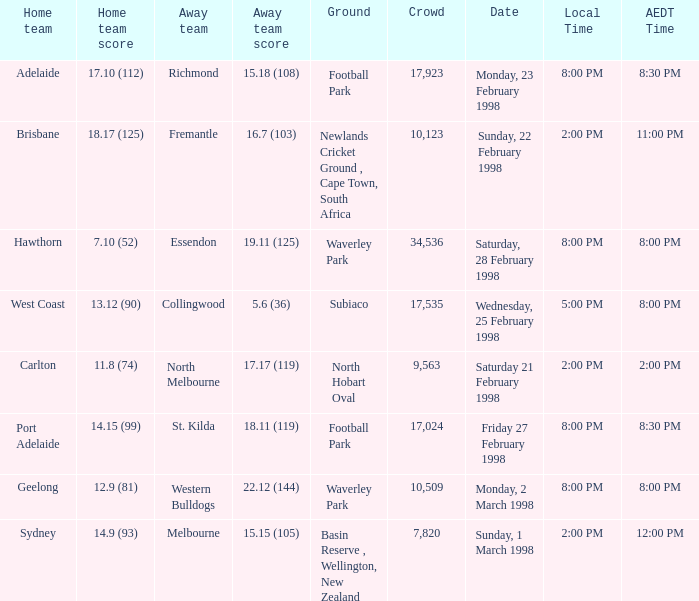Could you help me parse every detail presented in this table? {'header': ['Home team', 'Home team score', 'Away team', 'Away team score', 'Ground', 'Crowd', 'Date', 'Local Time', 'AEDT Time'], 'rows': [['Adelaide', '17.10 (112)', 'Richmond', '15.18 (108)', 'Football Park', '17,923', 'Monday, 23 February 1998', '8:00 PM', '8:30 PM'], ['Brisbane', '18.17 (125)', 'Fremantle', '16.7 (103)', 'Newlands Cricket Ground , Cape Town, South Africa', '10,123', 'Sunday, 22 February 1998', '2:00 PM', '11:00 PM'], ['Hawthorn', '7.10 (52)', 'Essendon', '19.11 (125)', 'Waverley Park', '34,536', 'Saturday, 28 February 1998', '8:00 PM', '8:00 PM'], ['West Coast', '13.12 (90)', 'Collingwood', '5.6 (36)', 'Subiaco', '17,535', 'Wednesday, 25 February 1998', '5:00 PM', '8:00 PM'], ['Carlton', '11.8 (74)', 'North Melbourne', '17.17 (119)', 'North Hobart Oval', '9,563', 'Saturday 21 February 1998', '2:00 PM', '2:00 PM'], ['Port Adelaide', '14.15 (99)', 'St. Kilda', '18.11 (119)', 'Football Park', '17,024', 'Friday 27 February 1998', '8:00 PM', '8:30 PM'], ['Geelong', '12.9 (81)', 'Western Bulldogs', '22.12 (144)', 'Waverley Park', '10,509', 'Monday, 2 March 1998', '8:00 PM', '8:00 PM'], ['Sydney', '14.9 (93)', 'Melbourne', '15.15 (105)', 'Basin Reserve , Wellington, New Zealand', '7,820', 'Sunday, 1 March 1998', '2:00 PM', '12:00 PM']]} Name the AEDT Time which has an Away team of collingwood? 8:00 PM. 